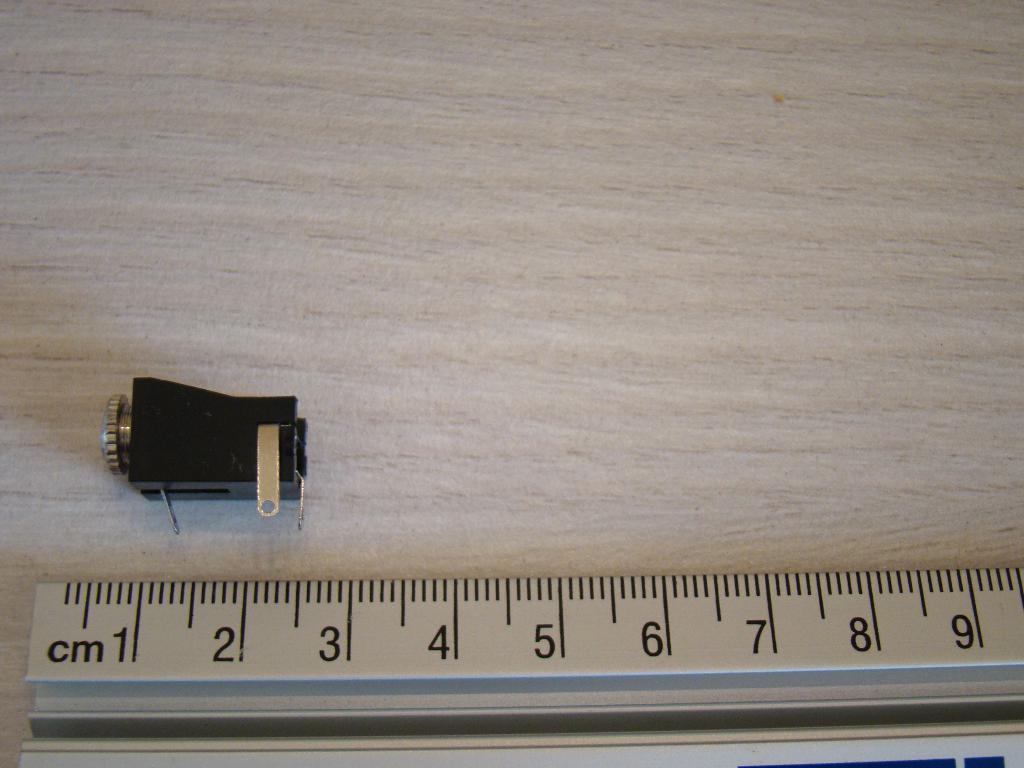How long is the object?
Your answer should be compact. 2 cm. What unit of measurement is written on the ruler?
Make the answer very short. Cm. 